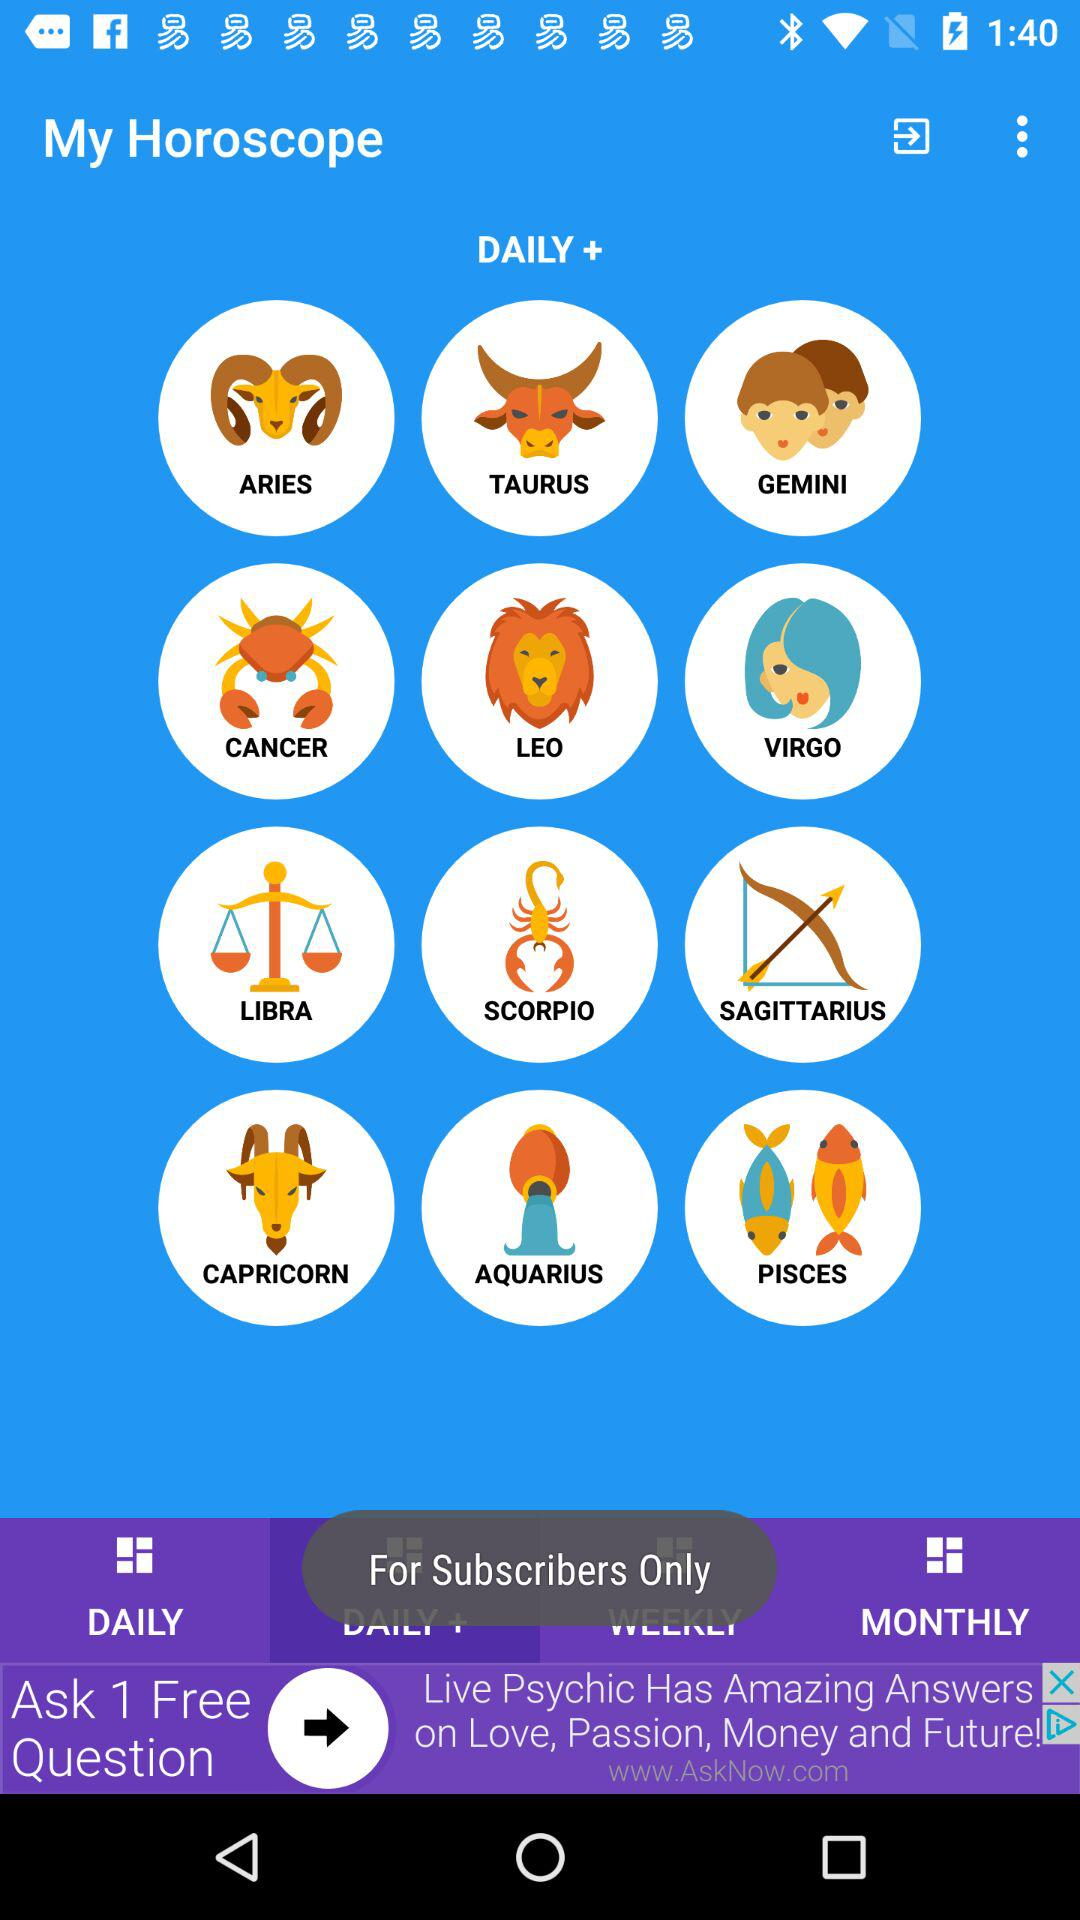What are the different available zodiac signs? The available zodiac signs are Aries, Taurus, Gemini, Cancer, Leo, Virgo, Libra, Scorpio, Sagittarius, Capricorn, Aquarius and Pisces. 